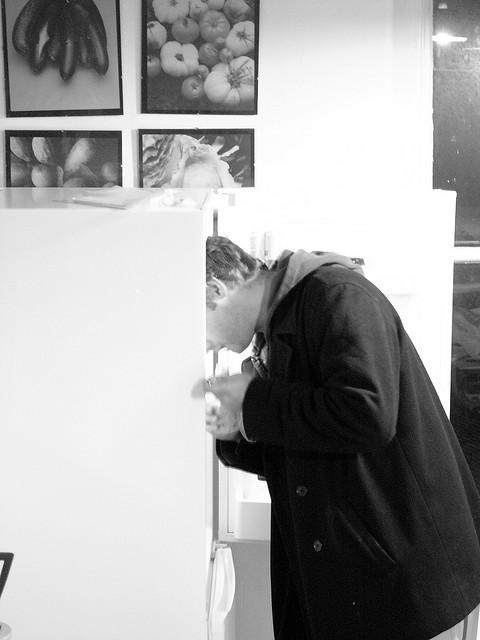How many pictures above the person's head?
Give a very brief answer. 4. What is the man doing?
Concise answer only. Looking in fridge. What is the color of man coat?
Short answer required. Black. What is the man looking into?
Write a very short answer. Refrigerator. 